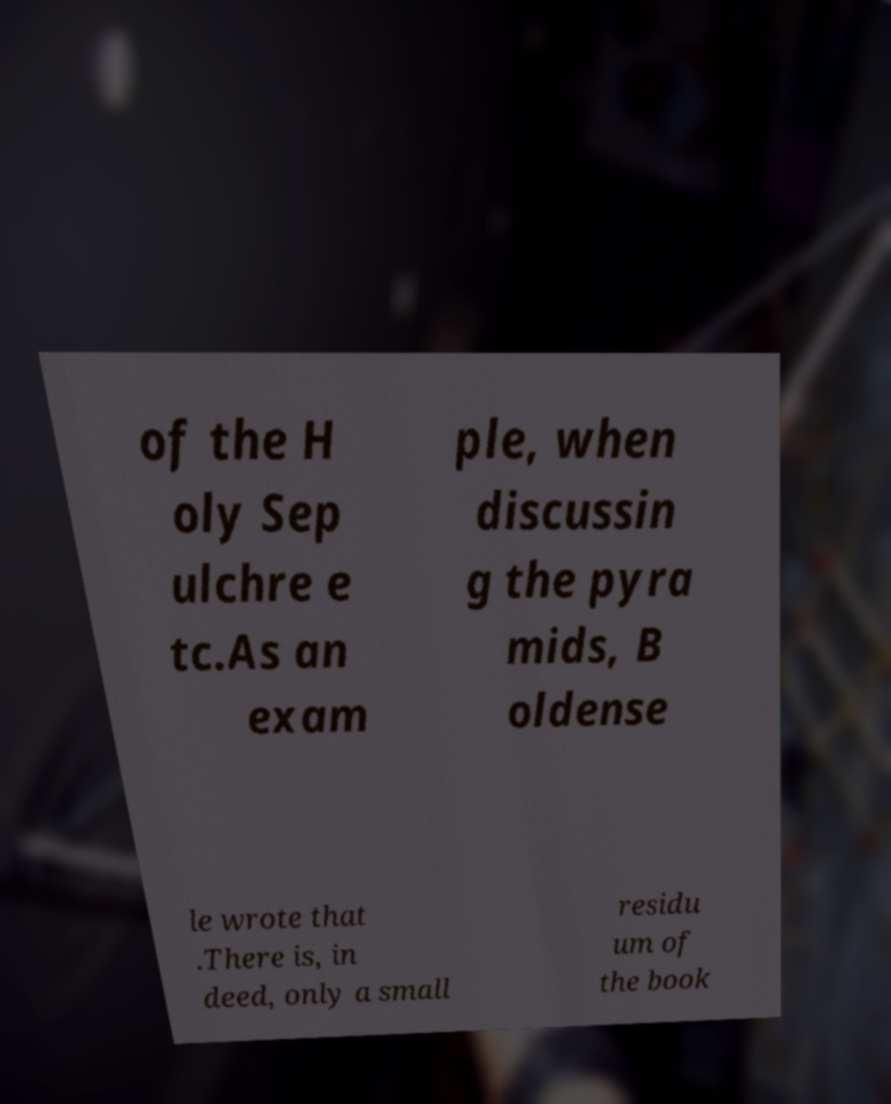Please read and relay the text visible in this image. What does it say? of the H oly Sep ulchre e tc.As an exam ple, when discussin g the pyra mids, B oldense le wrote that .There is, in deed, only a small residu um of the book 